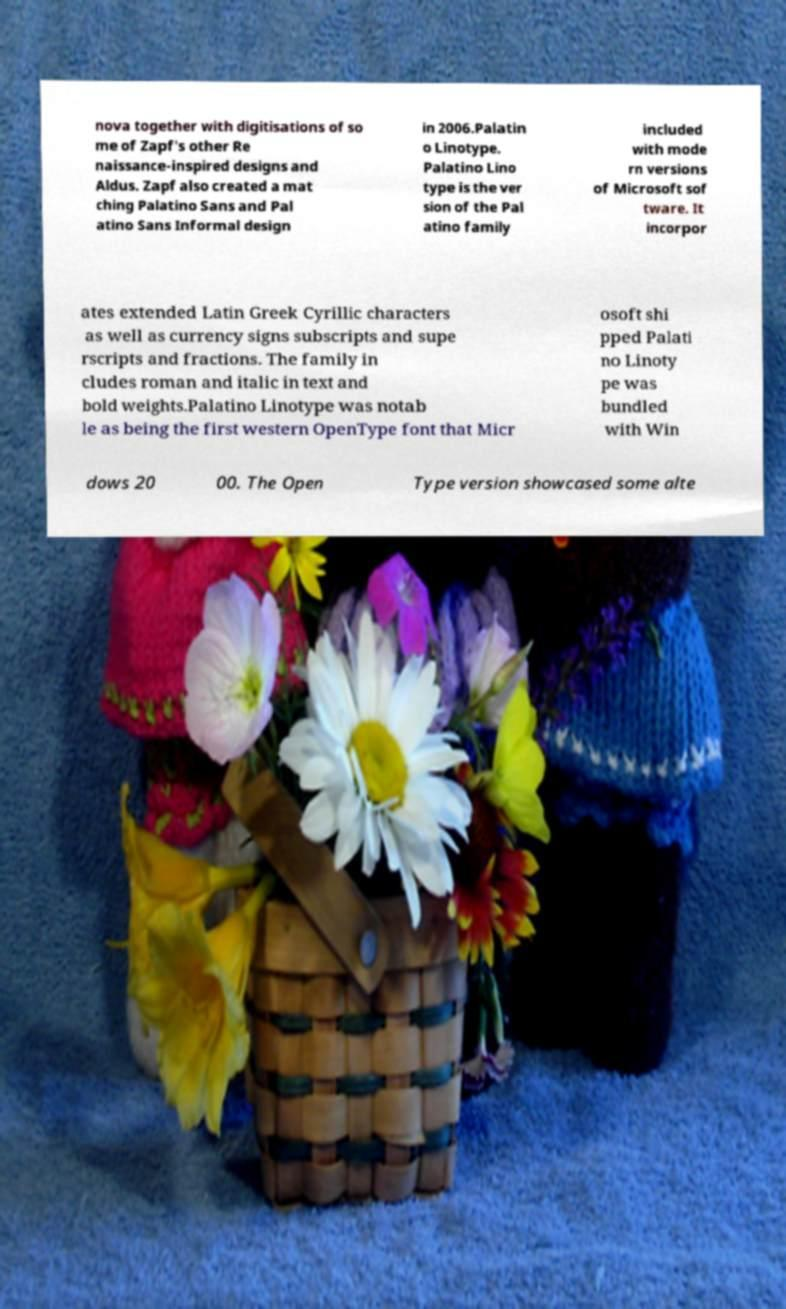What messages or text are displayed in this image? I need them in a readable, typed format. nova together with digitisations of so me of Zapf's other Re naissance-inspired designs and Aldus. Zapf also created a mat ching Palatino Sans and Pal atino Sans Informal design in 2006.Palatin o Linotype. Palatino Lino type is the ver sion of the Pal atino family included with mode rn versions of Microsoft sof tware. It incorpor ates extended Latin Greek Cyrillic characters as well as currency signs subscripts and supe rscripts and fractions. The family in cludes roman and italic in text and bold weights.Palatino Linotype was notab le as being the first western OpenType font that Micr osoft shi pped Palati no Linoty pe was bundled with Win dows 20 00. The Open Type version showcased some alte 